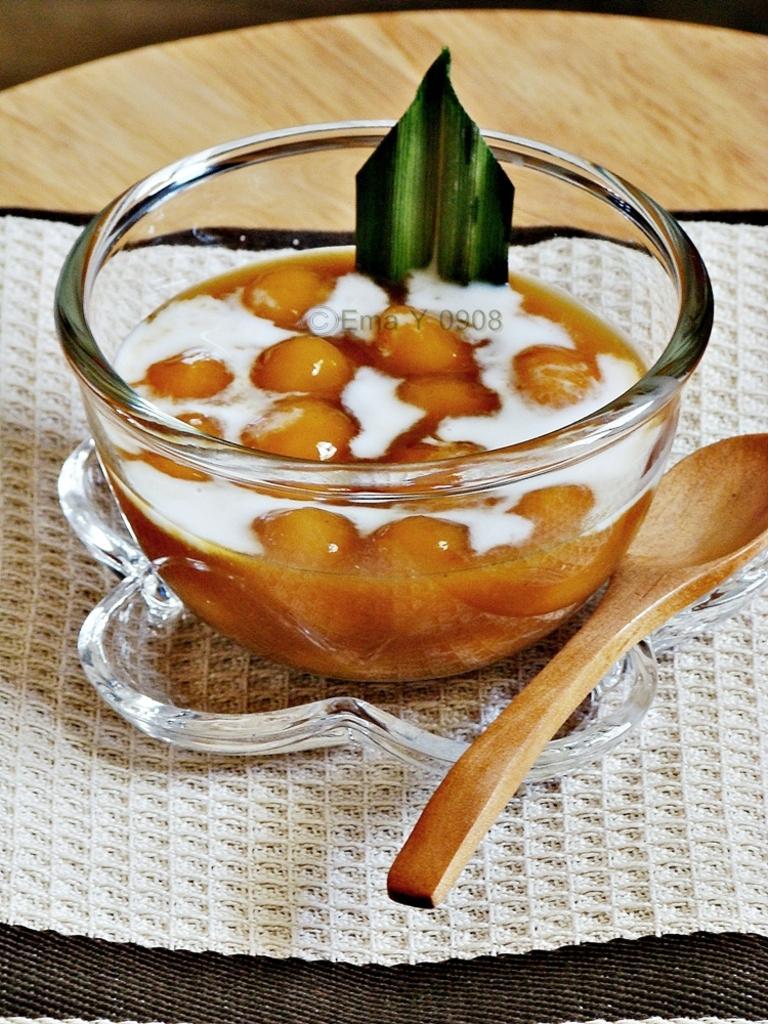Can you describe this image briefly? In this picture there is an edible placed in a bowl and there is a wooden spoon beside it. 